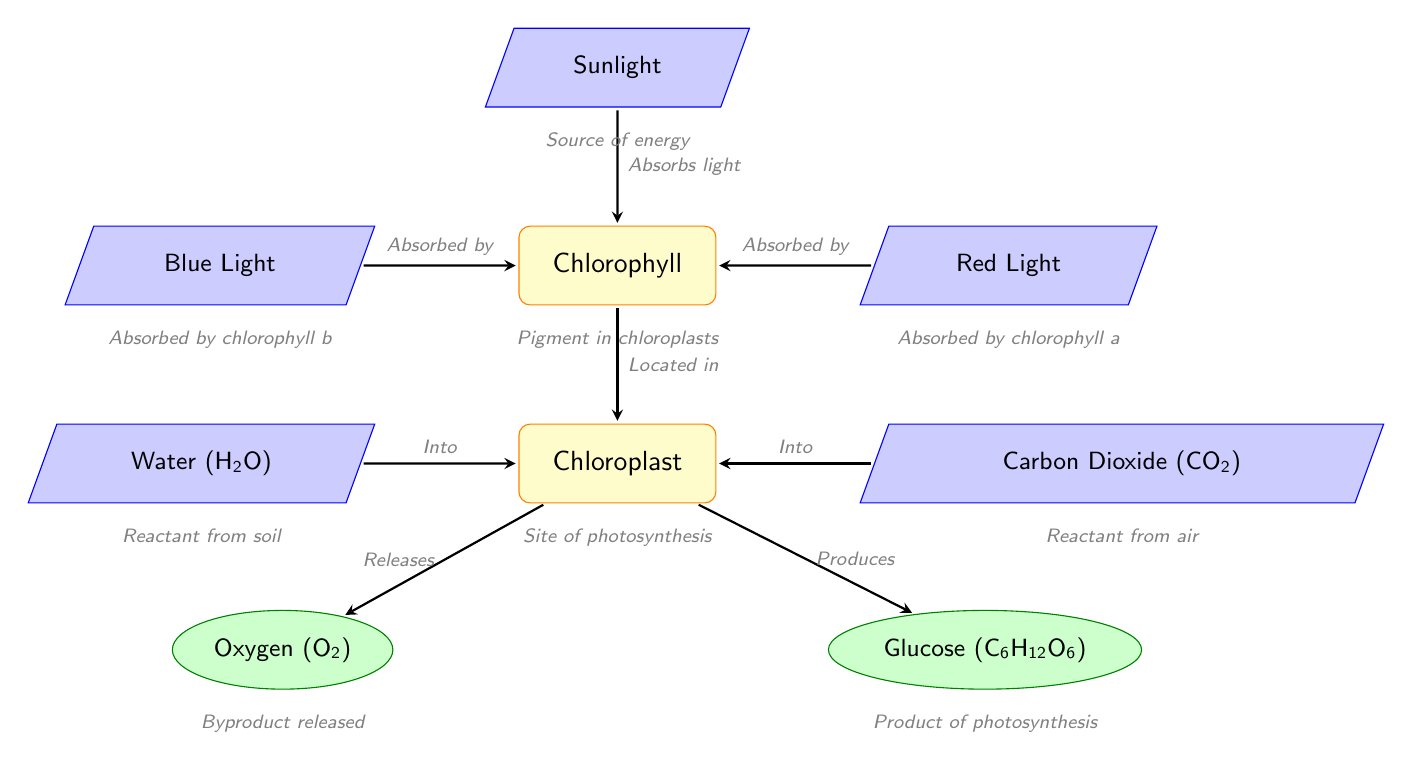What is the input on the left of the chloroplast? The diagram shows "Water (H2O)" as the input on the left side of the chloroplast, indicating it is one of the reactants that enters the photosynthesis process.
Answer: Water (H2O) How many processes are involved in the diagram? By counting the nodes labeled as processes, we find there are three: Chlorophyll, Chloroplast, and one more node that indicates they are all processes involved in photosynthesis.
Answer: 3 What does chlorophyll absorb? The diagram shows that chlorophyll absorbs both "Blue Light" and "Red Light." Since the question is about what chlorophyll absorbs, we can conclude that it absorbs both light types.
Answer: Blue Light and Red Light What is produced by the chloroplast? The outputs from the chloroplast are "Oxygen (O2)" and "Glucose (C6H12O6)." The direct product of photosynthesis, in this case, is glucose.
Answer: Glucose (C6H12O6) What role does chlorophyll play in photosynthesis? Chlorophyll is depicted as a pigment that is crucial for the absorption of light in the diagram, which is required for the photosynthesis process to occur in the chloroplast.
Answer: Pigment in chloroplasts How many inputs are there in total? By identifying the input nodes in the diagram, there are five total inputs: Sunlight, Water, Carbon Dioxide, Blue Light, and Red Light. Therefore, the total number of inputs can be deduced from counting these distinct nodes.
Answer: 5 What byproduct is released during photosynthesis? The diagram indicates that "Oxygen (O2)" is released as a byproduct of the chloroplast during the photosynthesis process. Thus, the answer focuses on the byproduct that exits the chloroplast.
Answer: Oxygen (O2) Which light is absorbed by chlorophyll a? According to the diagram, red light is specifically indicated as being absorbed by chlorophyll a, distinguishing its role in the absorption of light during photosynthesis.
Answer: Red Light 